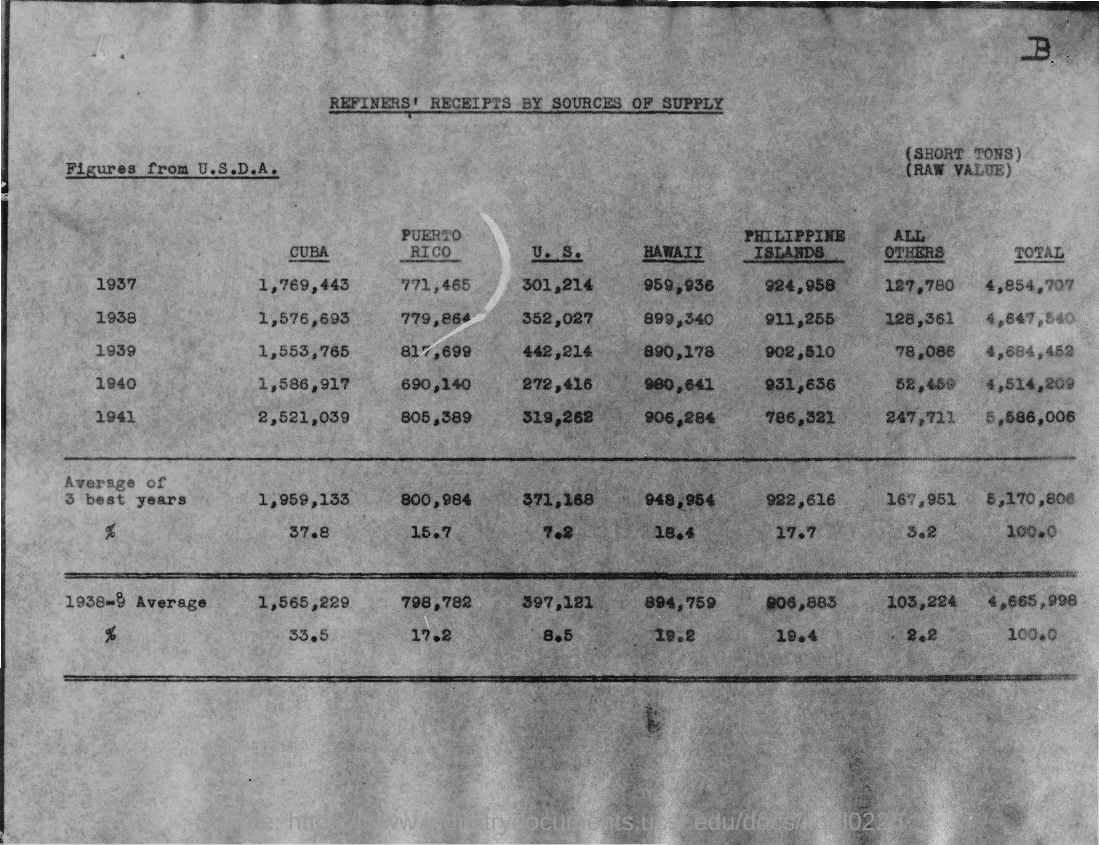Draw attention to some important aspects in this diagram. In 1938, the total was 4,647,540. The total from 1937 is 4,854,707. In 1939, the total was 4,684,452. In 1941, the total was 5,586,006. In 1940, the total was 4,514,209. 